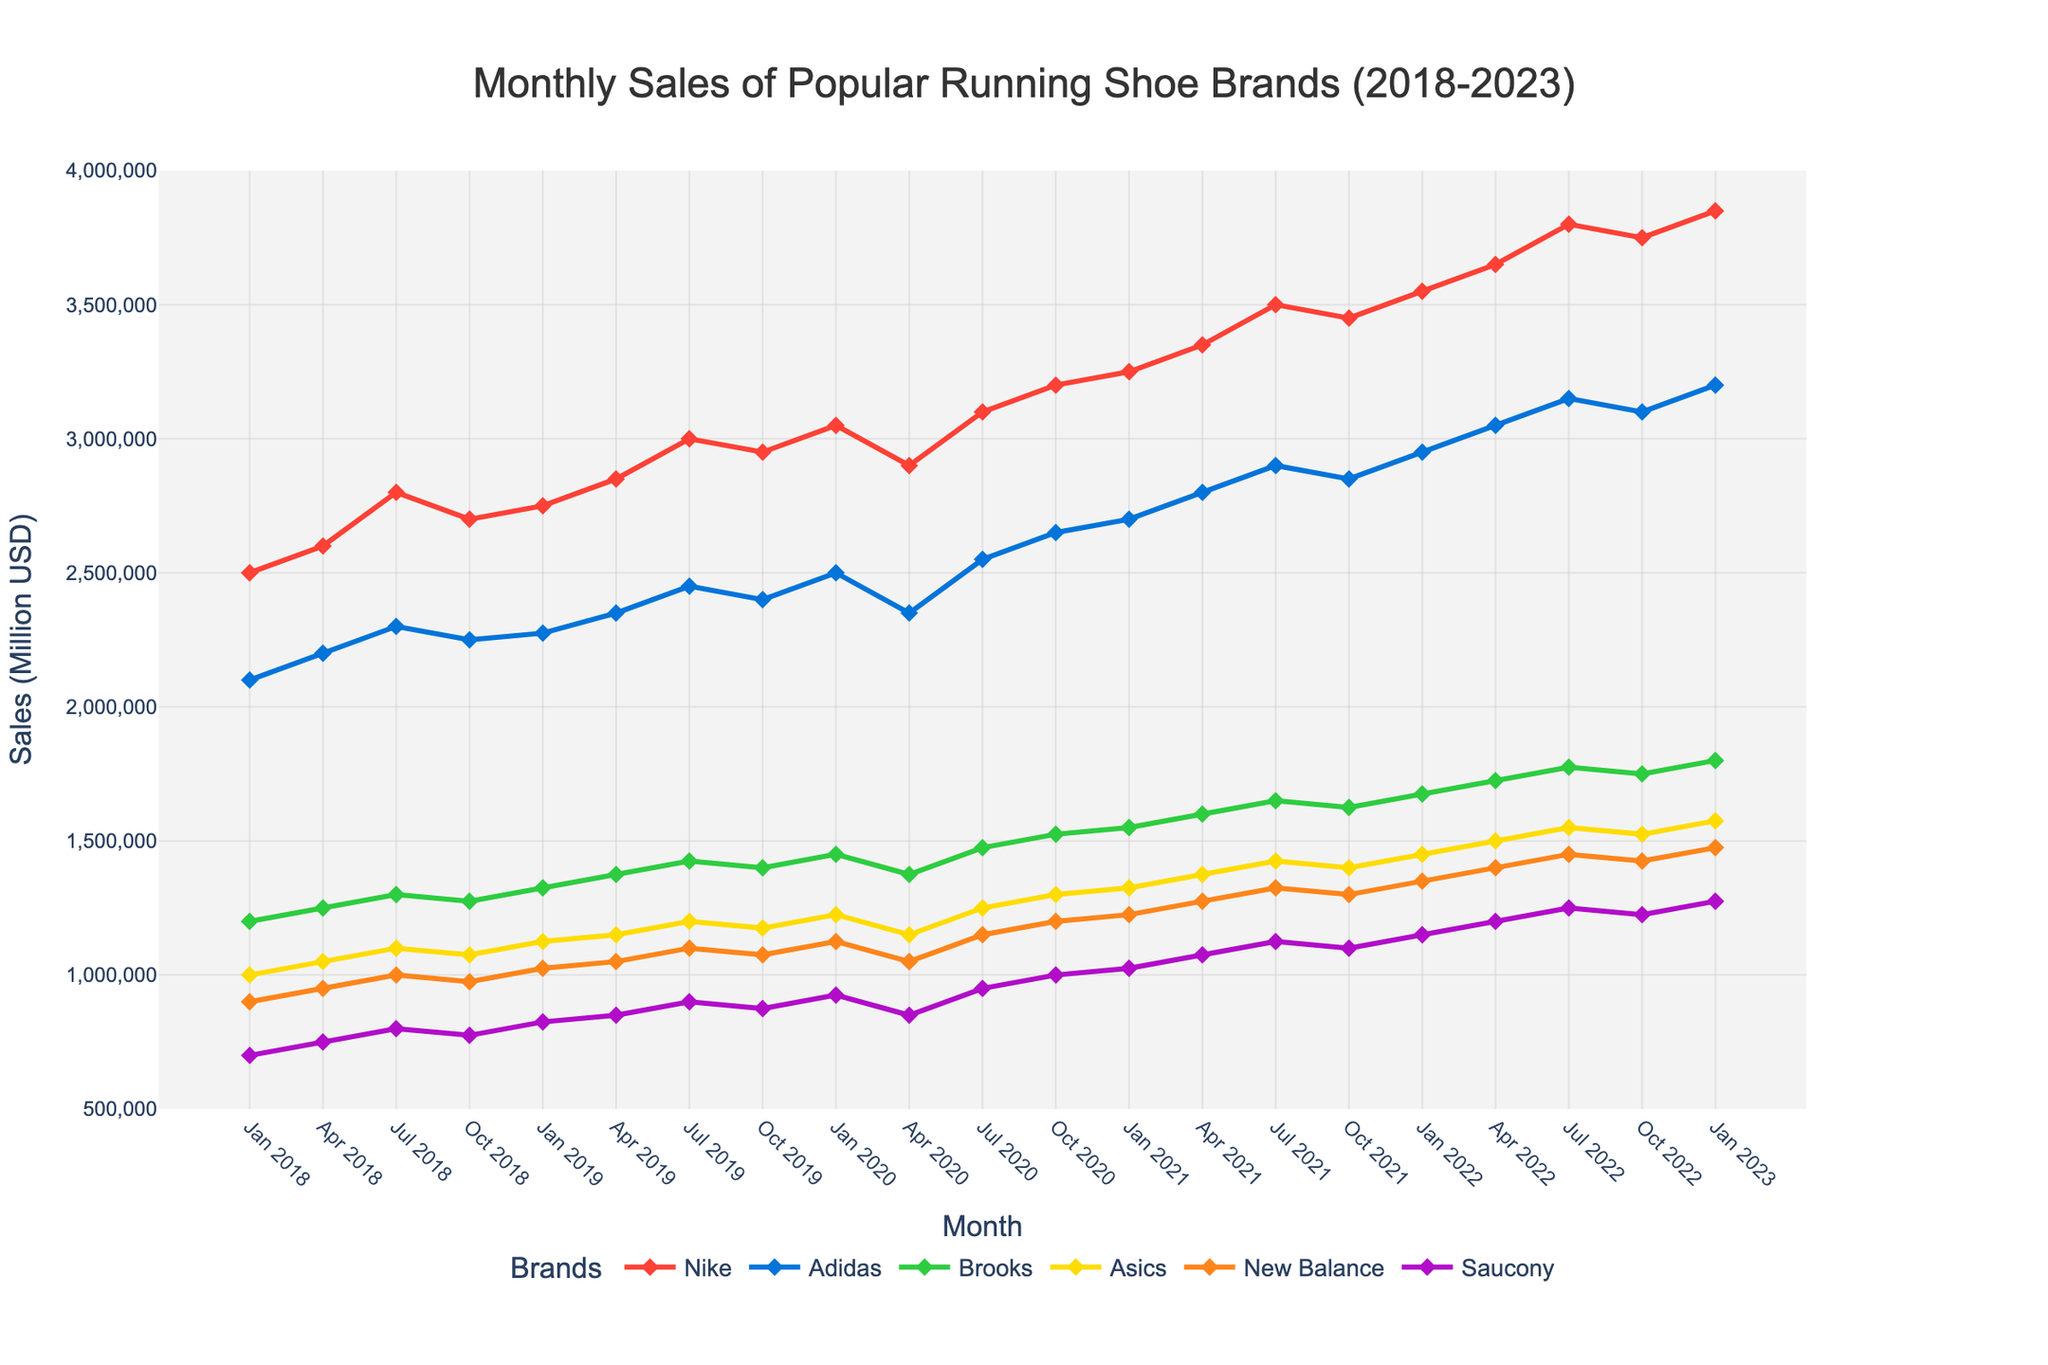Which brand had the highest sales in January 2023? Look for the data points corresponding to January 2023 and identify the brand with the highest y-axis value. Nike had the highest sales at 3.85 million USD.
Answer: Nike How did Nike's sales change from January 2018 to January 2023? Compare the y-axis values for Nike in January 2018 and January 2023. The sales increased from 2.5 million USD to 3.85 million USD.
Answer: Increased Which brand showed the most consistent sales increase over the entire period? Visually inspect the lines for each brand from start to end. Identify the line that consistently rises without significant drops. Nike has the most consistent upward trajectory.
Answer: Nike Which two brands had a sales crossover between April 2020 and July 2020? Identify the two lines that intersect between these months. Nike and Adidas have a crossover during this period.
Answer: Nike and Adidas By how much did Saucony's sales increase from January 2018 to January 2023? Subtract Saucony's sales value in January 2018 (0.7 million USD) from the value in January 2023 (1.275 million USD). The increase is 1.275 - 0.7 = 0.575 million USD.
Answer: 0.575 million USD During which month of 2022 did Brooks achieve the highest sales? Check each data point for Brooks in 2022 and identify the month with the highest y-axis value. Brooks achieved the highest sales in July 2022.
Answer: July 2022 Which brand showed the largest sales drop between consecutive quarters? Identify the largest vertical drop between any two consecutive data points for each brand. Adidas showed the largest drop between January 2021 and April 2021.
Answer: Adidas Were New Balance's sales higher or lower than Asics' sales in October 2018? Compare the y-axis values for New Balance and Asics in October 2018. New Balance had lower sales (0.975 million USD) than Asics (1.075 million USD).
Answer: Lower Which quarter of 2020 saw a significant dip in sales for multiple brands? Visually inspect the lines to find a quarter in 2020 where multiple brands saw a drop in y-axis values. The second quarter (April 2020) saw a dip for multiple brands, including Nike, Adidas, and Brooks.
Answer: April 2020 What is the average sales value for Adidas across all shown months? Sum all the sales values for Adidas and divide by the number of data points (21 months). (2100000 + 2200000 + 2300000 + 2250000 + 2275000 + 2350000 + 2450000 + 2400000 + 2500000 + 2350000 + 2550000 + 2650000 + 2700000 + 2800000 + 2900000 + 2850000 + 2950000 + 3050000 + 3150000 + 3100000 + 3200000) / 21 = 2642857.14 USD
Answer: 2,642,857.14 USD 